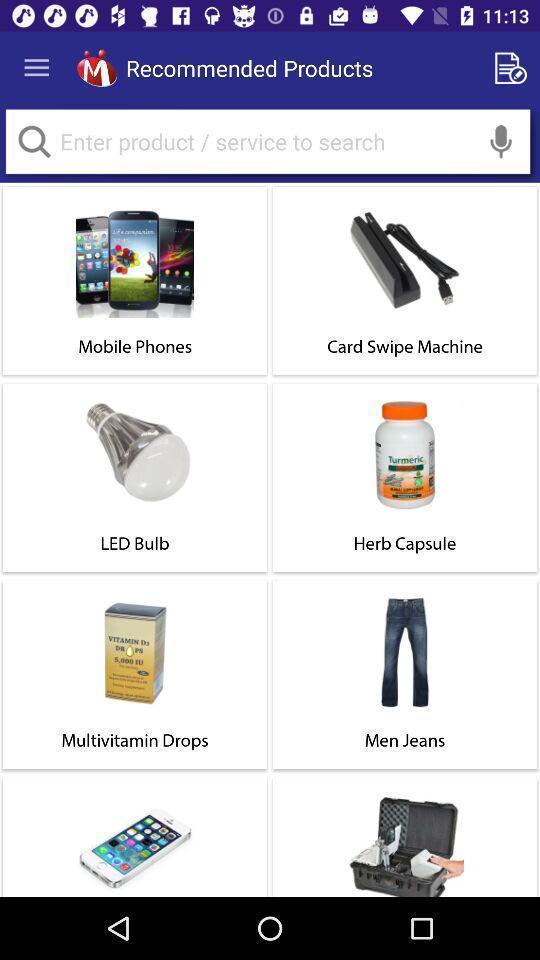Summarize the information in this screenshot. Page displays various products in a shopping app. 